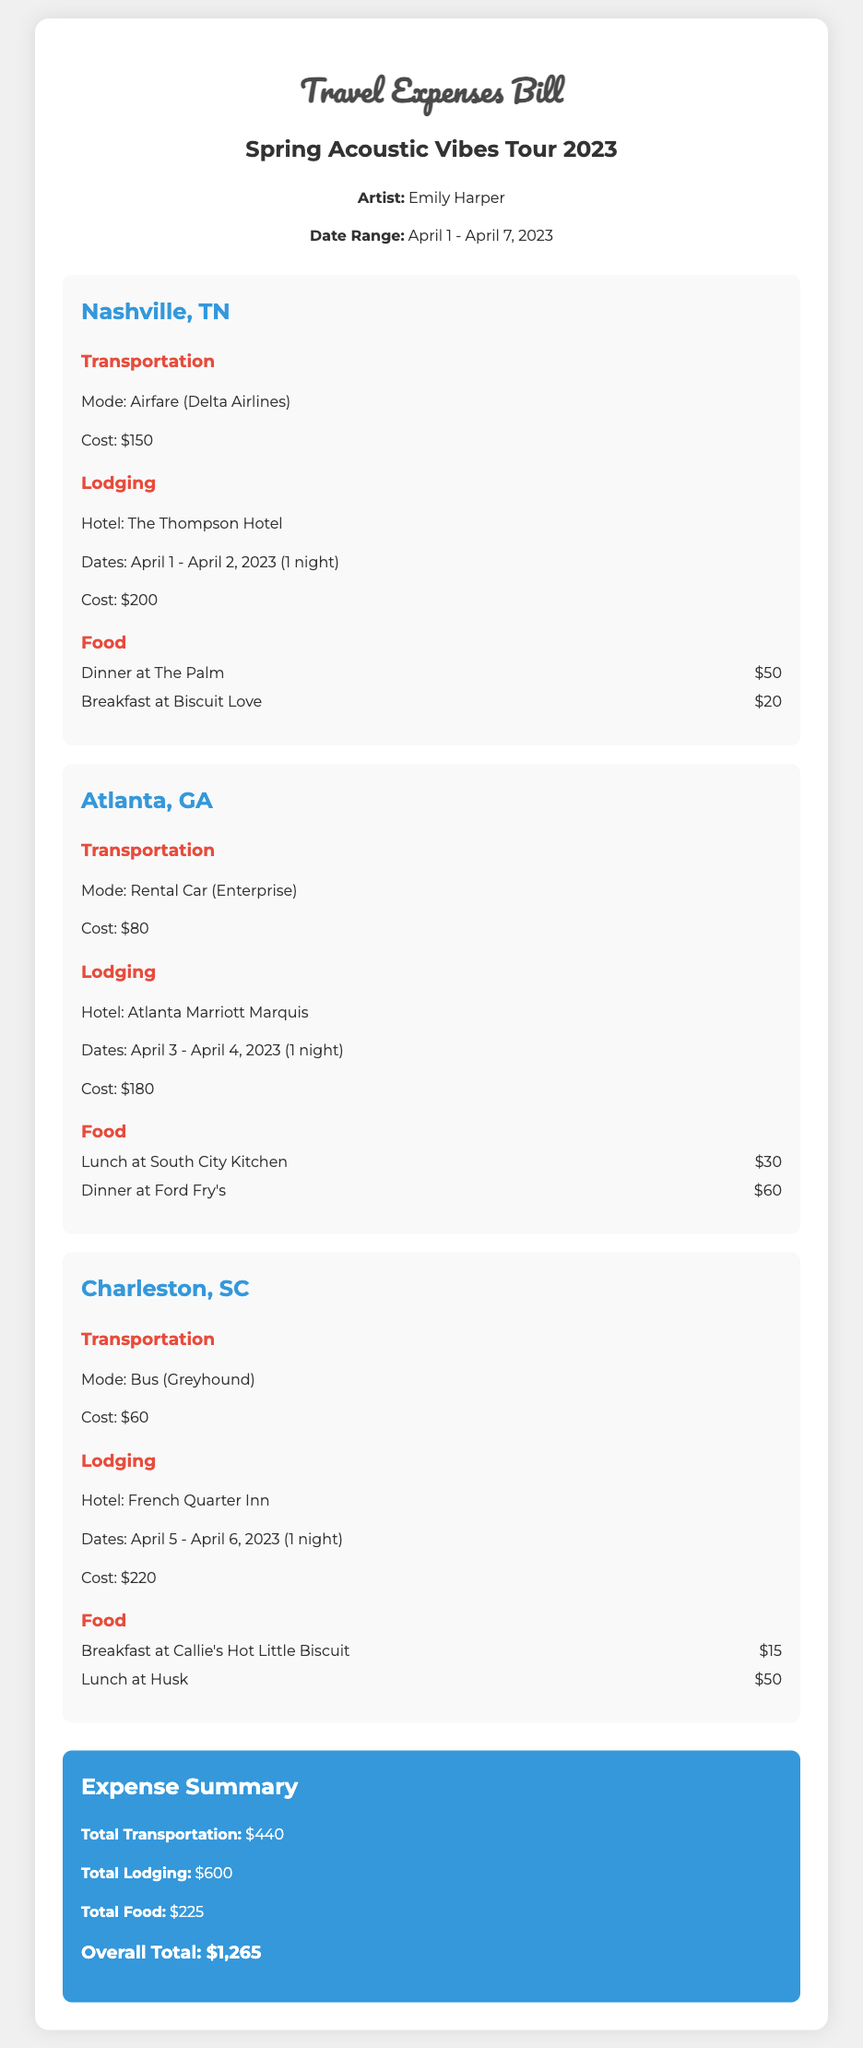What is the name of the artist? The document includes the artist's name as "Emily Harper."
Answer: Emily Harper What were the dates of the tour? The dates of the tour are specified as "April 1 - April 7, 2023."
Answer: April 1 - April 7, 2023 What was the cost of lodging in Nashville? The lodging expense for Nashville is listed as "$200."
Answer: $200 How much did the artist spend on food in Atlanta? The total food cost in Atlanta is the sum of lunch and dinner, which is $30 + $60 = $90.
Answer: $90 What is the total transportation cost for the tour? The document sums all transportation expenses, which is "$150 + $80 + $60 = $290."
Answer: $290 What hotel was used in Charleston? The hotel in Charleston is mentioned as "French Quarter Inn."
Answer: French Quarter Inn How long did the artist stay in Atlanta? The document specifies a stay in Atlanta for "1 night."
Answer: 1 night What was the overall total for expenses? The overall total is clearly stated as "$1,265."
Answer: $1,265 What meals were taken in Nashville? The meals listed in Nashville include dinner at "The Palm" for $50 and breakfast at "Biscuit Love" for $20.
Answer: Dinner at The Palm, Breakfast at Biscuit Love 